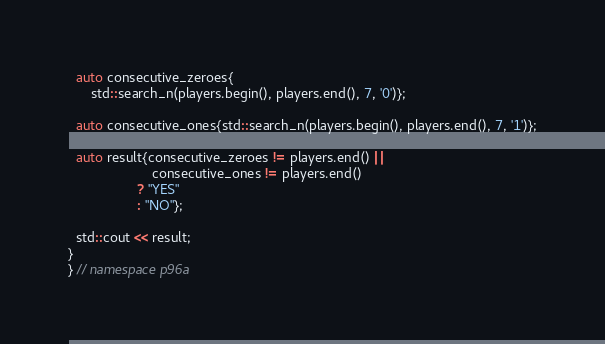Convert code to text. <code><loc_0><loc_0><loc_500><loc_500><_C++_>  auto consecutive_zeroes{
      std::search_n(players.begin(), players.end(), 7, '0')};

  auto consecutive_ones{std::search_n(players.begin(), players.end(), 7, '1')};

  auto result{consecutive_zeroes != players.end() ||
                      consecutive_ones != players.end()
                  ? "YES"
                  : "NO"};

  std::cout << result;
}
} // namespace p96a
</code> 